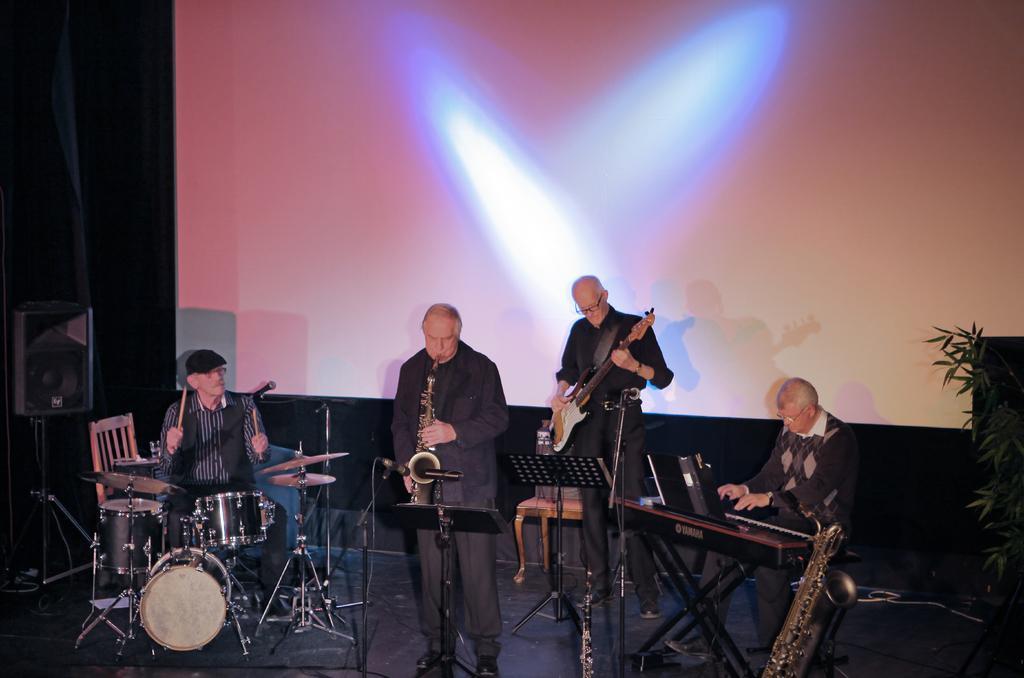Can you describe this image briefly? In the picture I can see people among them some are standing on the stage and some are sitting on chairs. These people are playing musical instruments. In the background I can see a projector screen, chairs, a plant and some other objects on the stage. 